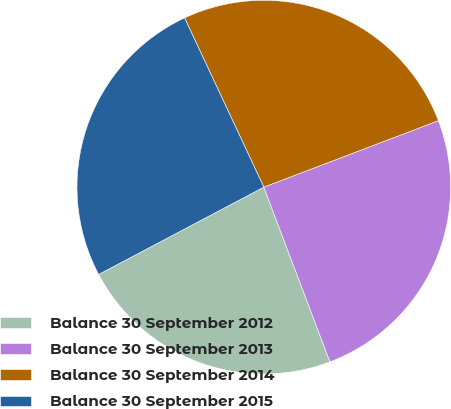<chart> <loc_0><loc_0><loc_500><loc_500><pie_chart><fcel>Balance 30 September 2012<fcel>Balance 30 September 2013<fcel>Balance 30 September 2014<fcel>Balance 30 September 2015<nl><fcel>23.02%<fcel>25.03%<fcel>26.18%<fcel>25.77%<nl></chart> 